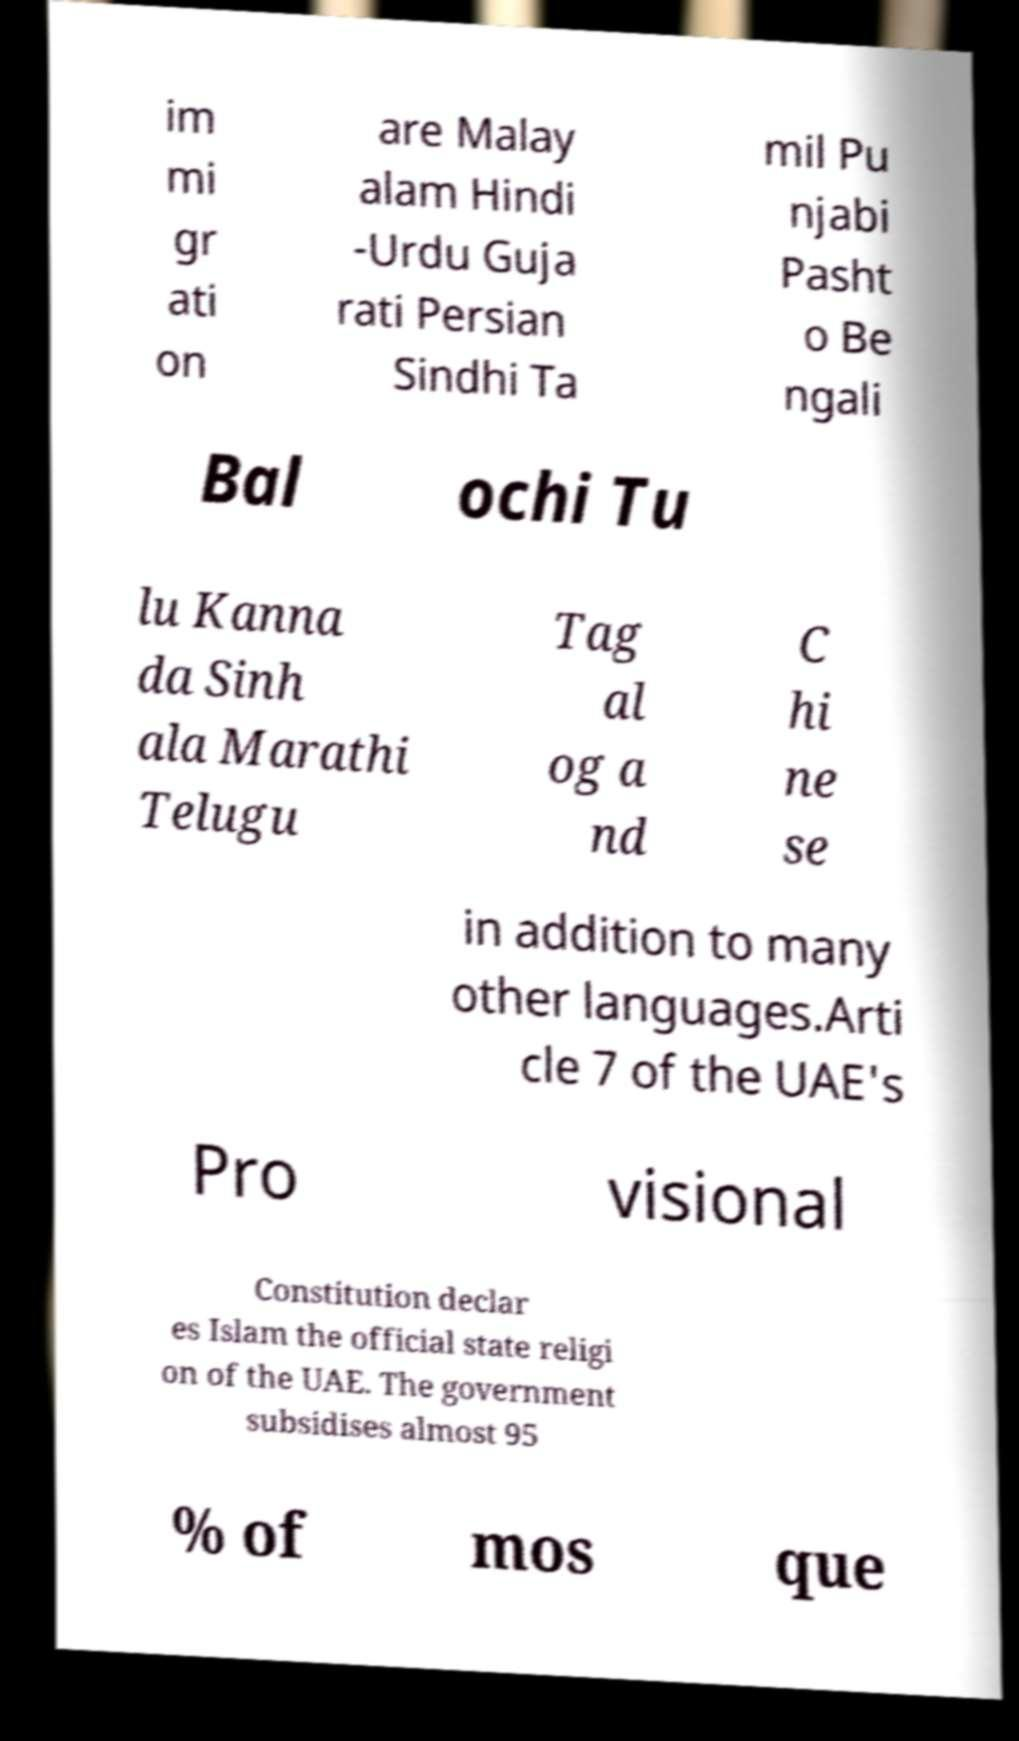Can you accurately transcribe the text from the provided image for me? im mi gr ati on are Malay alam Hindi -Urdu Guja rati Persian Sindhi Ta mil Pu njabi Pasht o Be ngali Bal ochi Tu lu Kanna da Sinh ala Marathi Telugu Tag al og a nd C hi ne se in addition to many other languages.Arti cle 7 of the UAE's Pro visional Constitution declar es Islam the official state religi on of the UAE. The government subsidises almost 95 % of mos que 